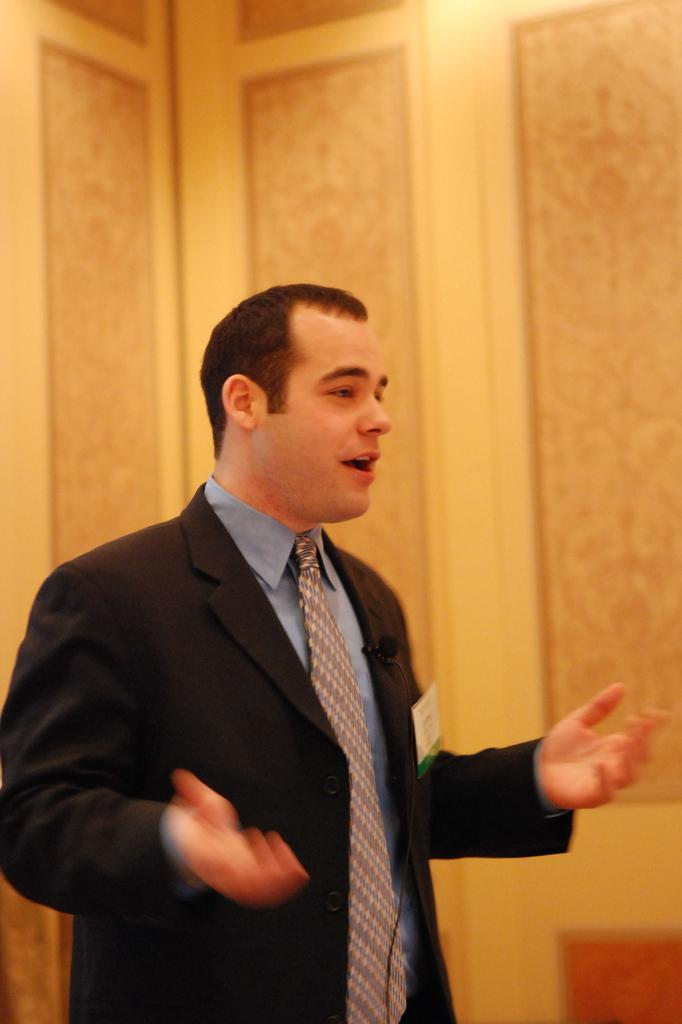What is the main subject of the image? There is a person in the image. What type of clothing is the person wearing? The person is wearing a tie, a shirt, and a suit. What is the color of the object in the image? The object in the image is black. What is attached to the person's suit? A card is visible on the person's suit. Can you tell me how the person is reacting to the cheese in the image? There is no cheese present in the image, so it is not possible to determine the person's reaction to it. 